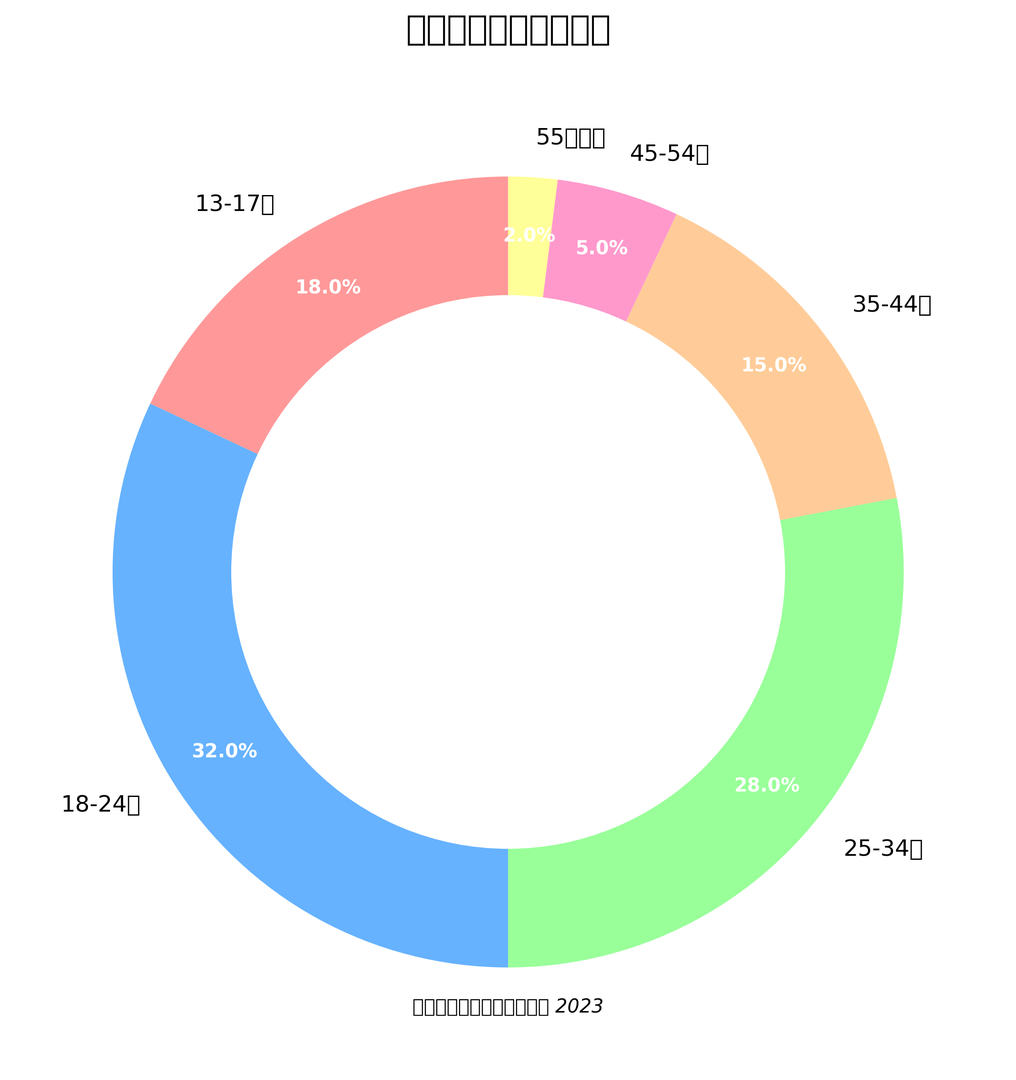What's the largest age group of 五月天歌迷? By observing the pie chart, we see that the "18-24歲" group has the largest section. Its percentage is prominently displayed as 32%, which is greater than any other age group.
Answer: 18-24歲 Which age group has the smallest percentage of 五月天歌迷? From the pie chart, it's evident that the "55歲以上" group has the smallest section. Its percentage is displayed as 2%, which is less than all other age groups.
Answer: 55歲以上 How much larger is the percentage of 五月天歌迷 in the 25-34歲 group compared to the 35-44歲 group? The 25-34歲 group has 28%, and the 35-44歲 group has 15%. Subtracting these two values, we get 28% - 15% = 13%.
Answer: 13% What is the combined percentage of 五月天歌迷 aged 45歲以上? Summing the percentages of the 45-54歲 and 55歲以上 groups, we get 5% + 2% = 7%.
Answer: 7% What is the difference in percentage between the two smallest_age groups and the two largest_age groups? The two smallest age groups are 45-54歲 (5%) and 55歲以上 (2%), with a total of 5% + 2% = 7%. The two largest age groups are 18-24歲 (32%) and 25-34歲 (28%), with a total of 32% + 28% = 60%. The difference is 60% - 7% = 53%.
Answer: 53% Identify the color associated with the group that has 18% of 五月天歌迷. The pie chart shows that the "13-17歲" group, which constitutes 18% of the fans, is colored in a light red shade.
Answer: Light red If the percentage of 五月天歌迷 in the 13-17歲 group increased by 4%, what would be the new percentage of this group? Adding 4% to the existing percentage of the 13-17歲 group (18%), we get 18% + 4% = 22%.
Answer: 22% What is the average percentage of 五月天歌迷 in the 25-34歲 and 35-44歲 groups? The 25-34歲 group has 28%, and the 35-44歲 group has 15%. The average is (28% + 15%) / 2 = 21.5%.
Answer: 21.5% Compare the number of groups with a percentage greater than 25% to those with a percentage less than 10%. Groups greater than 25%: 18-24歲 (32%) and 25-34歲 (28%), total 2 groups. Groups less than 10%: 45-54歲 (5%) and 55歲以上 (2%), total 2 groups. Both categories have an equal number of groups.
Answer: Equal number (2 each) 